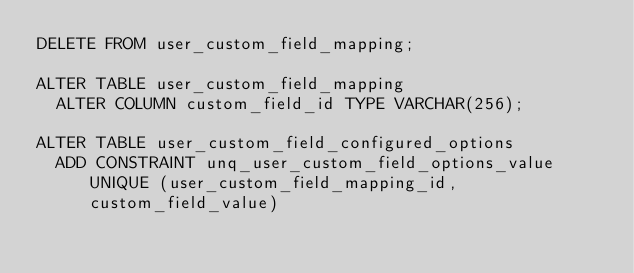<code> <loc_0><loc_0><loc_500><loc_500><_SQL_>DELETE FROM user_custom_field_mapping;

ALTER TABLE user_custom_field_mapping
  ALTER COLUMN custom_field_id TYPE VARCHAR(256);

ALTER TABLE user_custom_field_configured_options
  ADD CONSTRAINT unq_user_custom_field_options_value UNIQUE (user_custom_field_mapping_id, custom_field_value)
</code> 